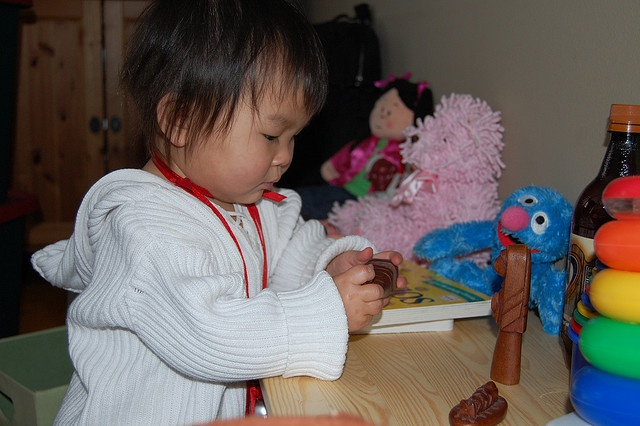Describe the objects in this image and their specific colors. I can see people in black, darkgray, and lightgray tones, teddy bear in black and gray tones, bottle in black, maroon, brown, and gray tones, book in black, darkgray, olive, and gray tones, and book in black, darkgray, and gray tones in this image. 